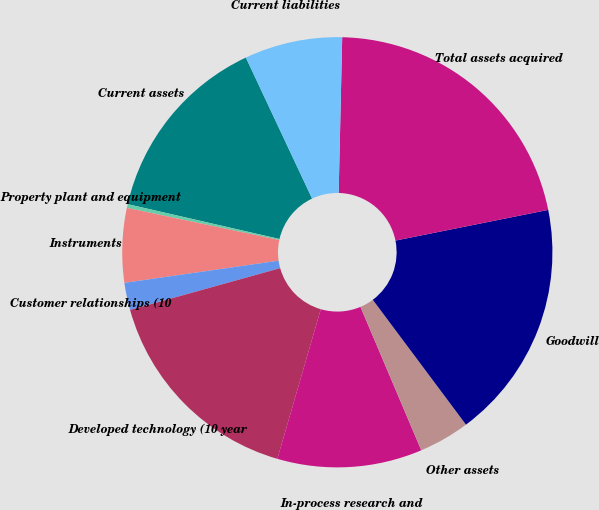Convert chart. <chart><loc_0><loc_0><loc_500><loc_500><pie_chart><fcel>Current assets<fcel>Property plant and equipment<fcel>Instruments<fcel>Customer relationships (10<fcel>Developed technology (10 year<fcel>In-process research and<fcel>Other assets<fcel>Goodwill<fcel>Total assets acquired<fcel>Current liabilities<nl><fcel>14.42%<fcel>0.28%<fcel>5.58%<fcel>2.05%<fcel>16.18%<fcel>10.88%<fcel>3.82%<fcel>17.95%<fcel>21.48%<fcel>7.35%<nl></chart> 